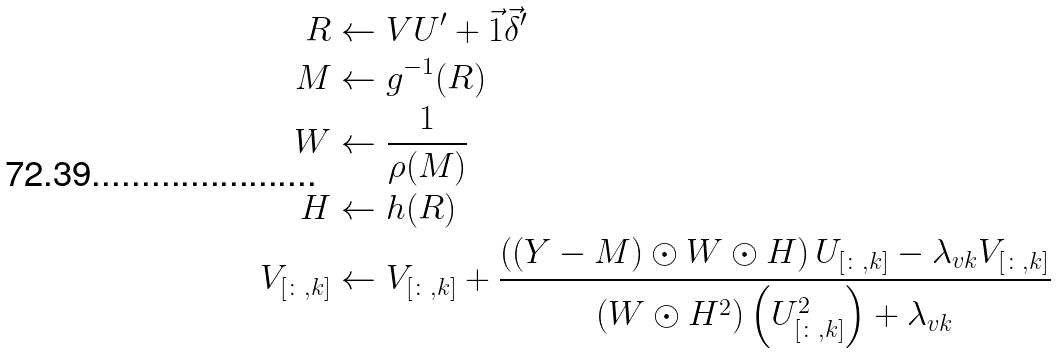<formula> <loc_0><loc_0><loc_500><loc_500>R & \gets V U ^ { \prime } + \vec { 1 } \vec { \delta } ^ { \prime } \\ M & \gets g ^ { - 1 } ( R ) \\ W & \gets \frac { 1 } { \rho ( M ) } \\ H & \gets h ( R ) \\ V _ { [ \colon , k ] } & \gets V _ { [ \colon , k ] } + \frac { \left ( ( Y - M ) \odot W \odot H \right ) U _ { [ \colon , k ] } - \lambda _ { v k } V _ { [ \colon , k ] } } { \left ( W \odot H ^ { 2 } \right ) \left ( U _ { [ \colon , k ] } ^ { 2 } \right ) + \lambda _ { v k } }</formula> 